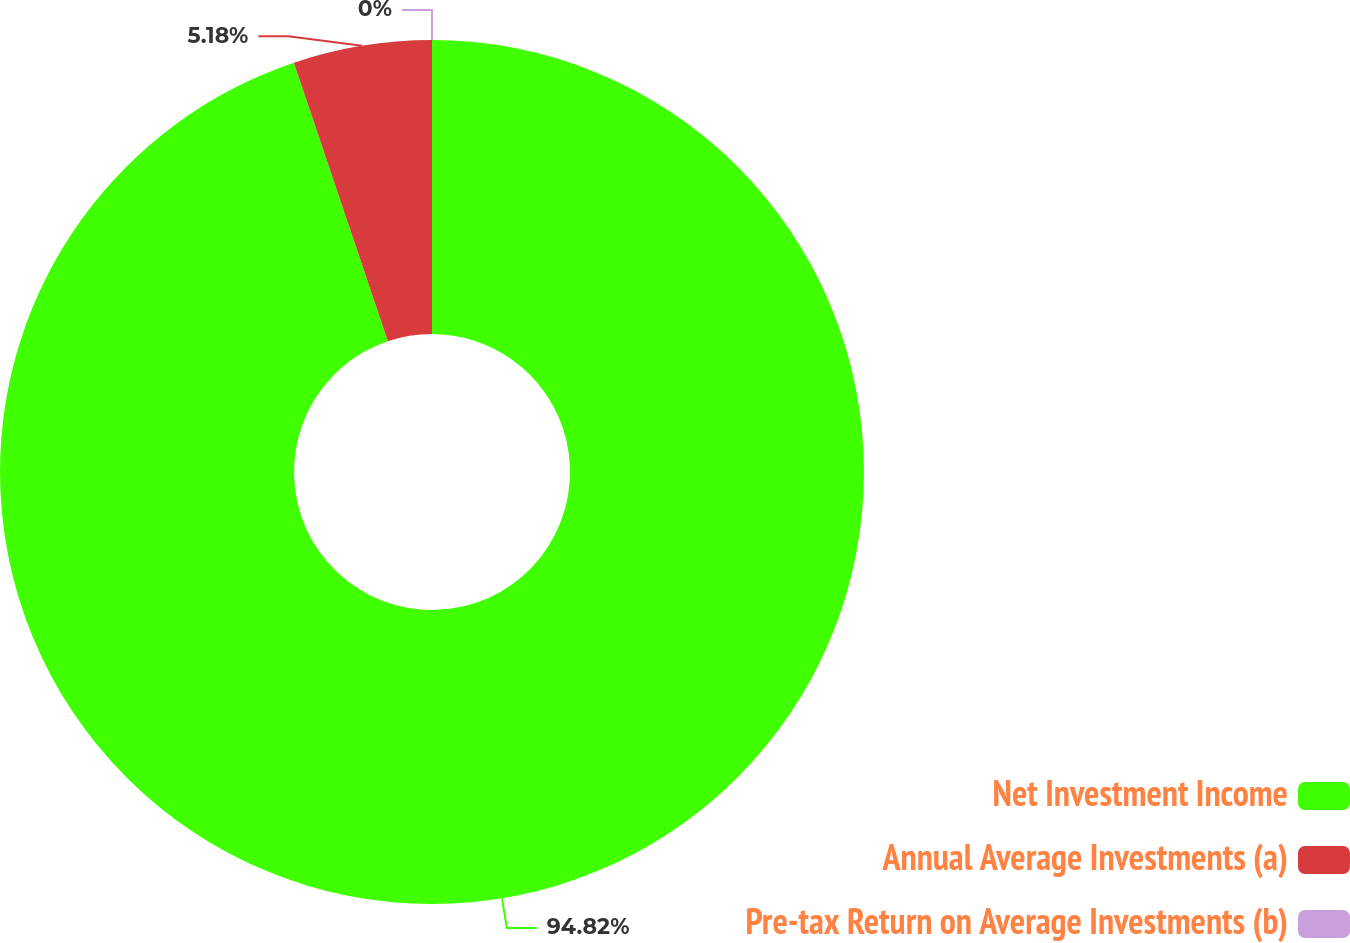Convert chart. <chart><loc_0><loc_0><loc_500><loc_500><pie_chart><fcel>Net Investment Income<fcel>Annual Average Investments (a)<fcel>Pre-tax Return on Average Investments (b)<nl><fcel>94.82%<fcel>5.18%<fcel>0.0%<nl></chart> 